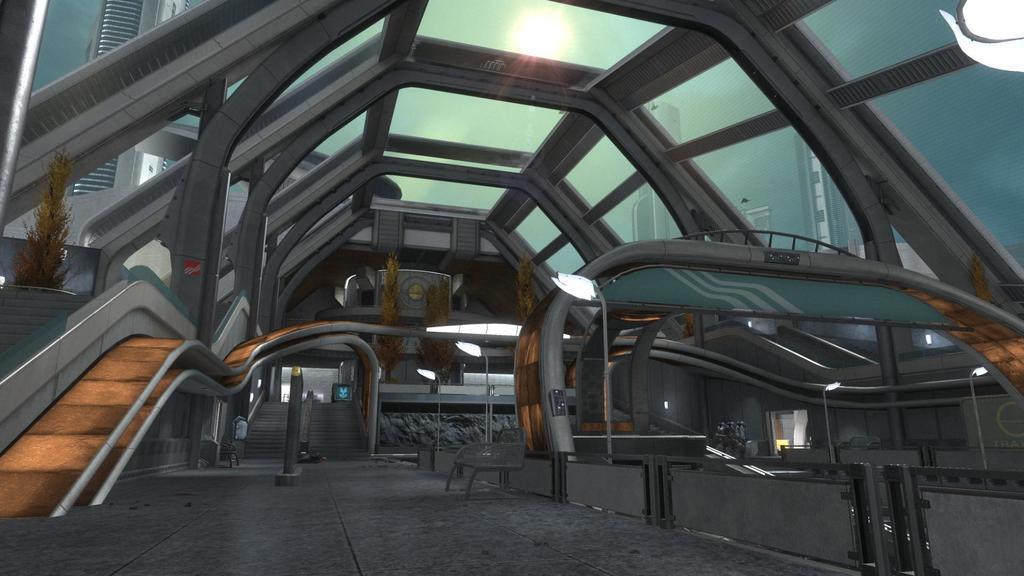Describe this image in one or two sentences. In the picture we can see inside view of the building with poles and lights to it and some benches, stairs, plant and from the glasses we can see a part of other buildings. 